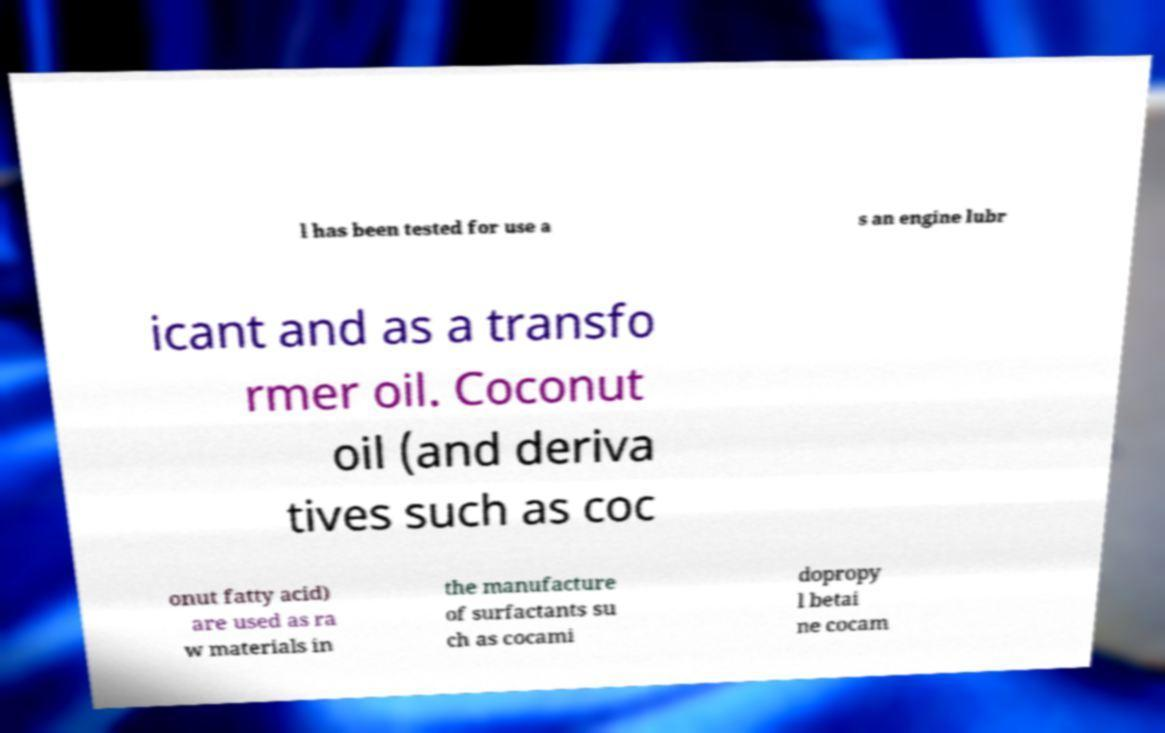For documentation purposes, I need the text within this image transcribed. Could you provide that? l has been tested for use a s an engine lubr icant and as a transfo rmer oil. Coconut oil (and deriva tives such as coc onut fatty acid) are used as ra w materials in the manufacture of surfactants su ch as cocami dopropy l betai ne cocam 